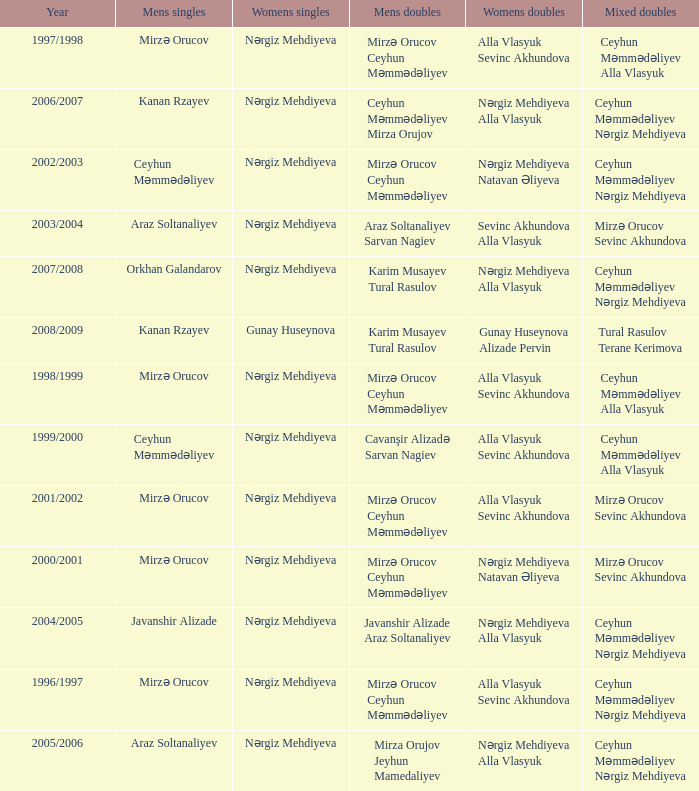Who were all womens doubles for the year 2000/2001? Nərgiz Mehdiyeva Natavan Əliyeva. 